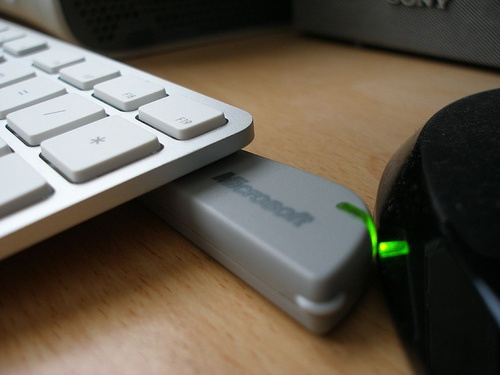Describe the objects in this image and their specific colors. I can see a keyboard in gray, lightgray, darkgray, and maroon tones in this image. 